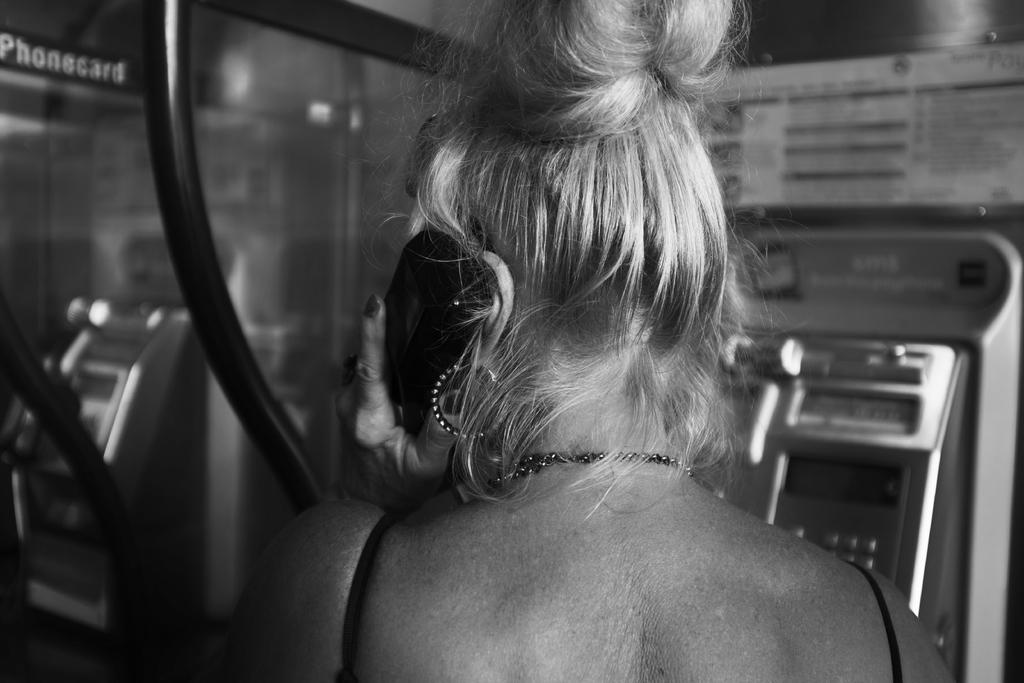What is the color scheme of the image? The image is black and white. Can you describe the person in the image? There is a person in the image. What is the person doing in the image? The person is holding the receiver of a telephone. Where is the person located in the image? The person is inside a telephone booth. What type of boat can be seen in the image? There is no boat present in the image; it features a person inside a telephone booth. What arithmetic problem is the person solving in the image? There is no arithmetic problem visible in the image; the person is holding a telephone receiver. 